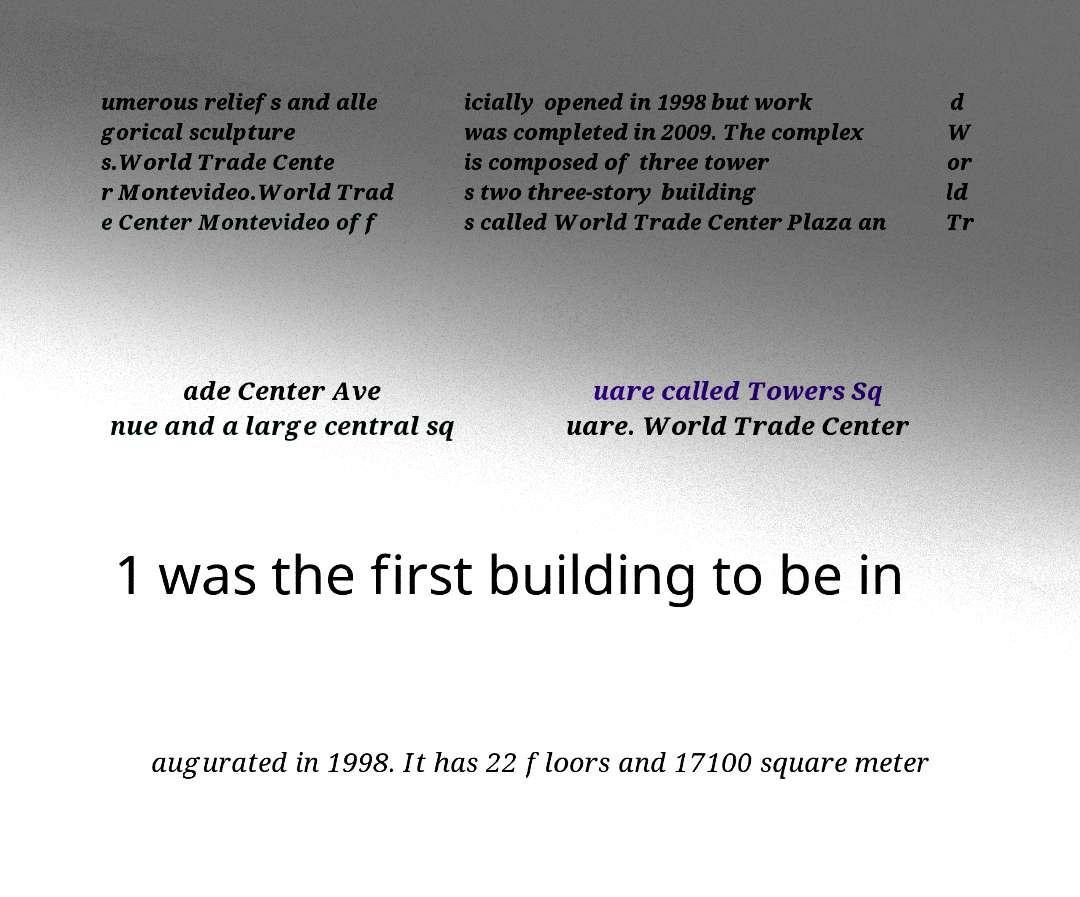I need the written content from this picture converted into text. Can you do that? umerous reliefs and alle gorical sculpture s.World Trade Cente r Montevideo.World Trad e Center Montevideo off icially opened in 1998 but work was completed in 2009. The complex is composed of three tower s two three-story building s called World Trade Center Plaza an d W or ld Tr ade Center Ave nue and a large central sq uare called Towers Sq uare. World Trade Center 1 was the first building to be in augurated in 1998. It has 22 floors and 17100 square meter 